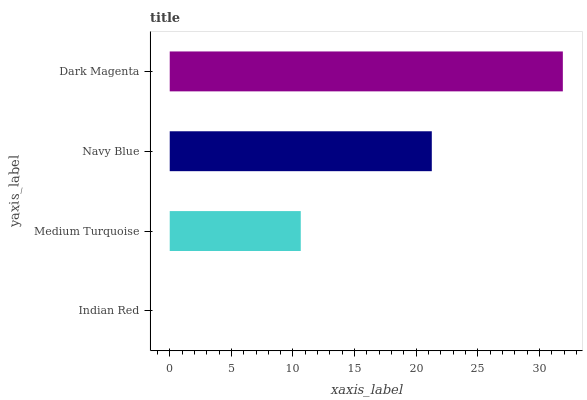Is Indian Red the minimum?
Answer yes or no. Yes. Is Dark Magenta the maximum?
Answer yes or no. Yes. Is Medium Turquoise the minimum?
Answer yes or no. No. Is Medium Turquoise the maximum?
Answer yes or no. No. Is Medium Turquoise greater than Indian Red?
Answer yes or no. Yes. Is Indian Red less than Medium Turquoise?
Answer yes or no. Yes. Is Indian Red greater than Medium Turquoise?
Answer yes or no. No. Is Medium Turquoise less than Indian Red?
Answer yes or no. No. Is Navy Blue the high median?
Answer yes or no. Yes. Is Medium Turquoise the low median?
Answer yes or no. Yes. Is Medium Turquoise the high median?
Answer yes or no. No. Is Dark Magenta the low median?
Answer yes or no. No. 